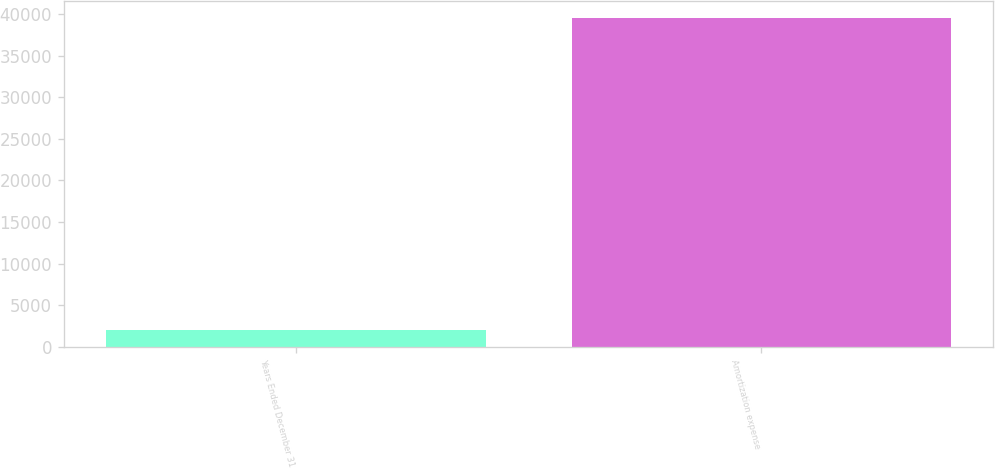Convert chart to OTSL. <chart><loc_0><loc_0><loc_500><loc_500><bar_chart><fcel>Years Ended December 31<fcel>Amortization expense<nl><fcel>2016<fcel>39545<nl></chart> 